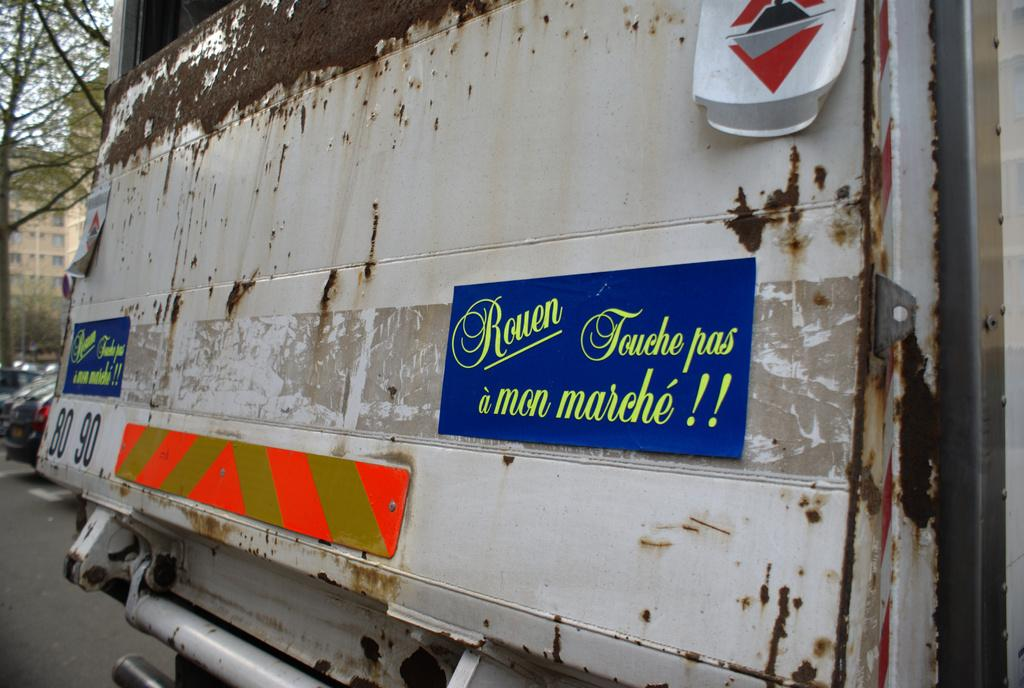What part of a vehicle is visible in the image? The back side of a vehicle is visible in the image. What else can be seen on the road in the image? There are cars on the road in the image. What type of natural scenery is visible in the background of the image? There are trees in the background of the image. What type of man-made structures are visible in the background of the image? There are buildings in the background of the image. What is visible in the sky in the image? The sky is visible in the background of the image. What type of orange can be seen growing on the vehicle in the image? There is no orange visible growing on the vehicle in the image. 